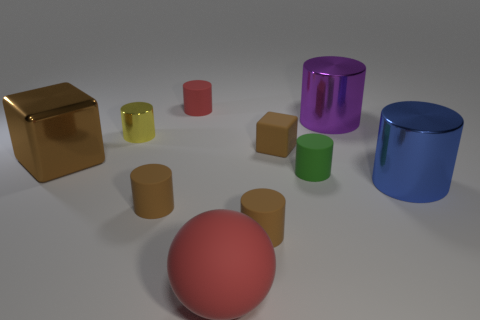Does the cube to the left of the small red cylinder have the same color as the tiny shiny object?
Provide a short and direct response. No. What number of things are both behind the small yellow metal cylinder and on the left side of the big purple object?
Give a very brief answer. 1. What number of other objects are there of the same material as the large red ball?
Provide a short and direct response. 5. Are the red thing that is in front of the big brown object and the blue thing made of the same material?
Ensure brevity in your answer.  No. There is a thing that is to the left of the metallic cylinder to the left of the red object that is in front of the large brown shiny cube; what size is it?
Offer a terse response. Large. How many other things are the same color as the large rubber object?
Ensure brevity in your answer.  1. There is a metal object that is the same size as the green rubber cylinder; what is its shape?
Your answer should be compact. Cylinder. How big is the brown block that is to the left of the big red rubber object?
Ensure brevity in your answer.  Large. Does the big cylinder that is behind the brown metal thing have the same color as the small matte cylinder behind the small green matte cylinder?
Offer a very short reply. No. What is the material of the cylinder that is in front of the small brown cylinder that is on the left side of the large object that is in front of the big blue metallic object?
Your answer should be compact. Rubber. 